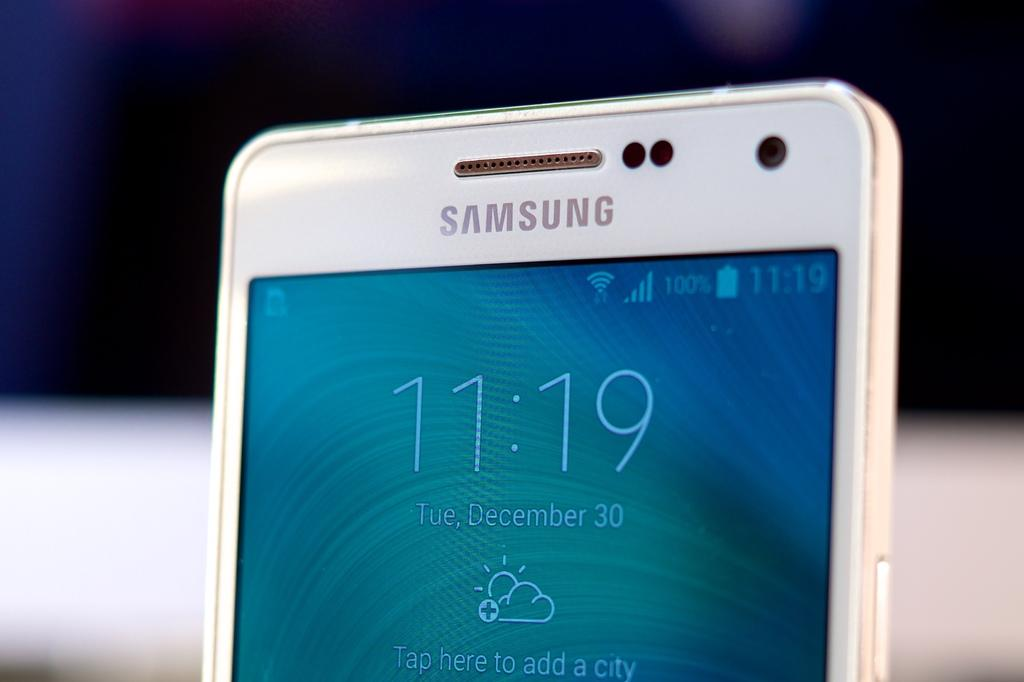<image>
Offer a succinct explanation of the picture presented. A close up of the top half of a Samsung cell phone. 